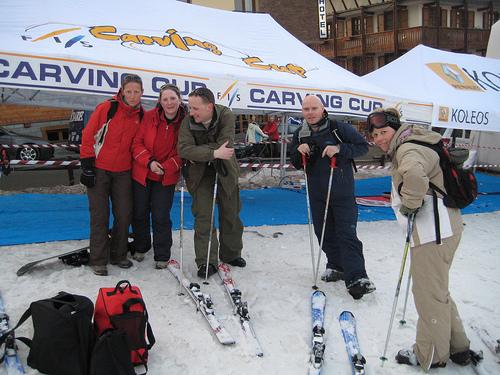What is written behind the woman?
Quick response, please. Carving cup. Is the person on the right wearing a brown jacket?
Answer briefly. Yes. What activity are these people doing?
Quick response, please. Skiing. How many people are looking at the camera?
Keep it brief. 4. 